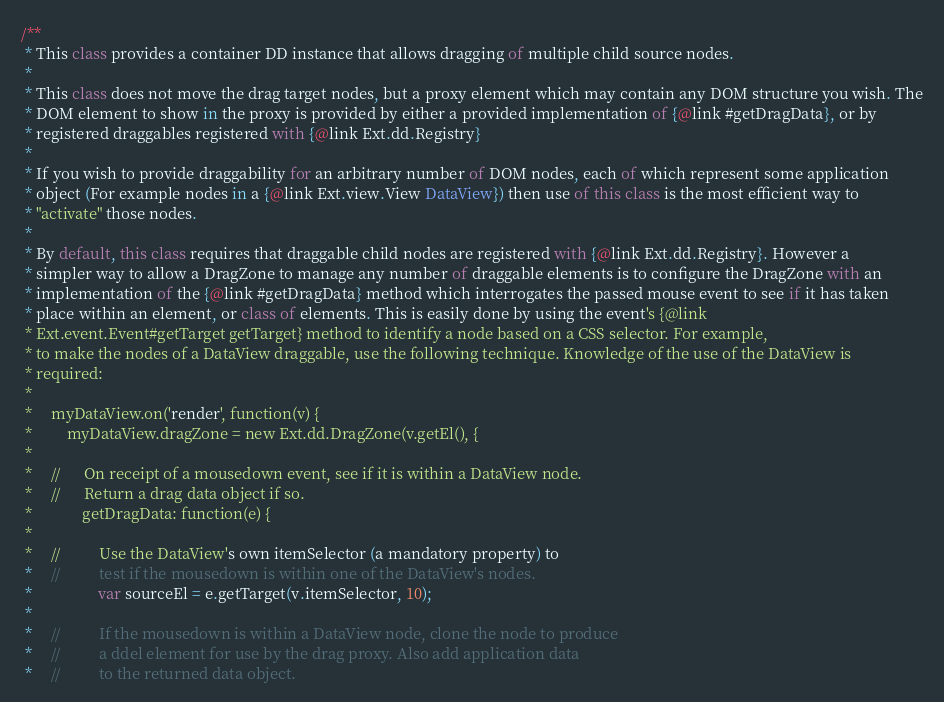<code> <loc_0><loc_0><loc_500><loc_500><_JavaScript_>/**
 * This class provides a container DD instance that allows dragging of multiple child source nodes.
 *
 * This class does not move the drag target nodes, but a proxy element which may contain any DOM structure you wish. The
 * DOM element to show in the proxy is provided by either a provided implementation of {@link #getDragData}, or by
 * registered draggables registered with {@link Ext.dd.Registry}
 *
 * If you wish to provide draggability for an arbitrary number of DOM nodes, each of which represent some application
 * object (For example nodes in a {@link Ext.view.View DataView}) then use of this class is the most efficient way to
 * "activate" those nodes.
 *
 * By default, this class requires that draggable child nodes are registered with {@link Ext.dd.Registry}. However a
 * simpler way to allow a DragZone to manage any number of draggable elements is to configure the DragZone with an
 * implementation of the {@link #getDragData} method which interrogates the passed mouse event to see if it has taken
 * place within an element, or class of elements. This is easily done by using the event's {@link
 * Ext.event.Event#getTarget getTarget} method to identify a node based on a CSS selector. For example,
 * to make the nodes of a DataView draggable, use the following technique. Knowledge of the use of the DataView is
 * required:
 *
 *     myDataView.on('render', function(v) {
 *         myDataView.dragZone = new Ext.dd.DragZone(v.getEl(), {
 *
 *     //      On receipt of a mousedown event, see if it is within a DataView node.
 *     //      Return a drag data object if so.
 *             getDragData: function(e) {
 *
 *     //          Use the DataView's own itemSelector (a mandatory property) to
 *     //          test if the mousedown is within one of the DataView's nodes.
 *                 var sourceEl = e.getTarget(v.itemSelector, 10);
 *
 *     //          If the mousedown is within a DataView node, clone the node to produce
 *     //          a ddel element for use by the drag proxy. Also add application data
 *     //          to the returned data object.</code> 